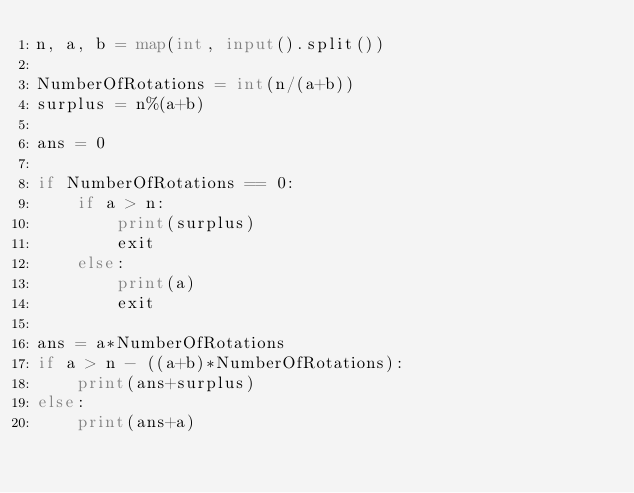<code> <loc_0><loc_0><loc_500><loc_500><_Python_>n, a, b = map(int, input().split())

NumberOfRotations = int(n/(a+b))
surplus = n%(a+b)

ans = 0

if NumberOfRotations == 0:
    if a > n:
        print(surplus)
        exit
    else:
        print(a)
        exit

ans = a*NumberOfRotations
if a > n - ((a+b)*NumberOfRotations):
    print(ans+surplus)
else:
    print(ans+a)</code> 